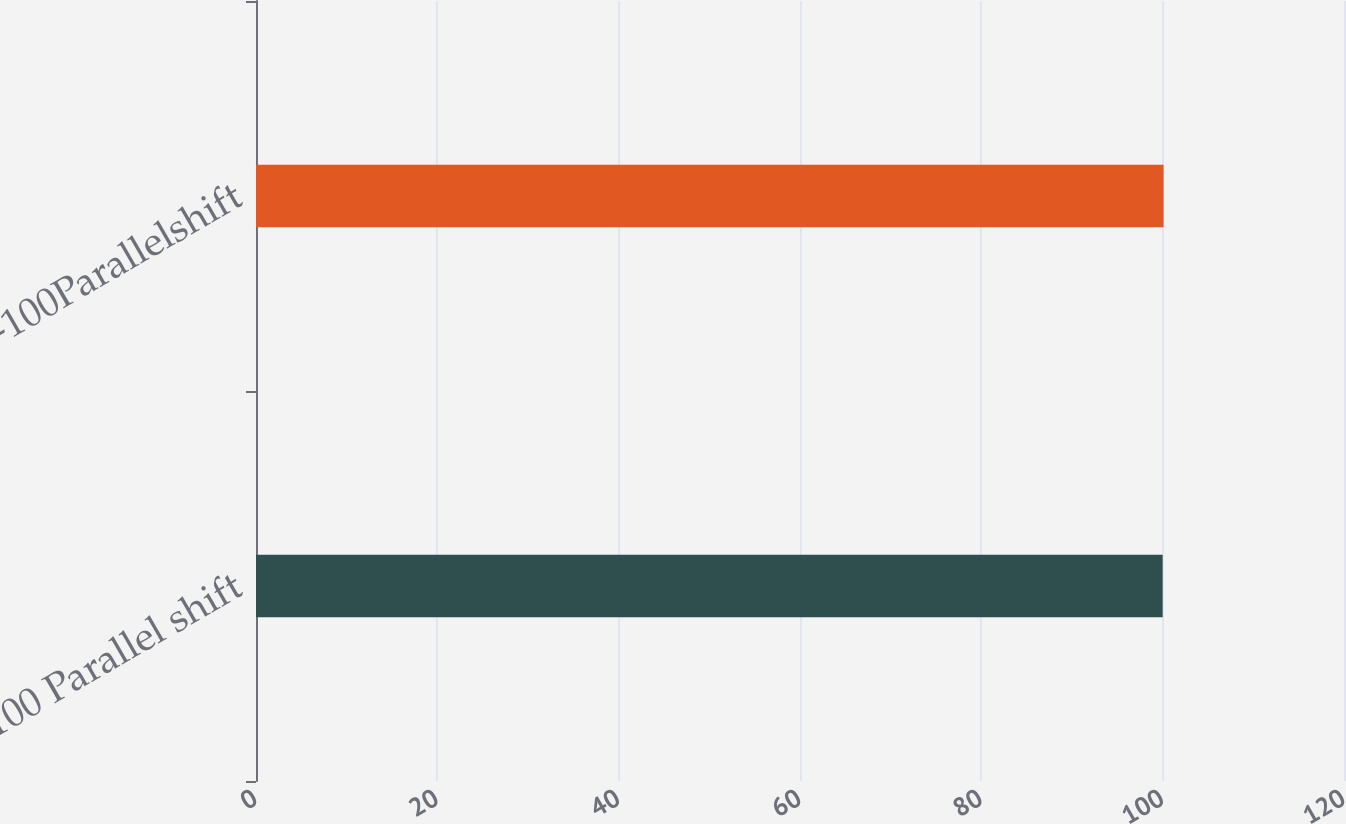<chart> <loc_0><loc_0><loc_500><loc_500><bar_chart><fcel>+100 Parallel shift<fcel>-100Parallelshift<nl><fcel>100<fcel>100.1<nl></chart> 